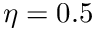Convert formula to latex. <formula><loc_0><loc_0><loc_500><loc_500>\eta = 0 . 5</formula> 